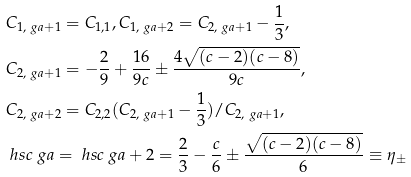Convert formula to latex. <formula><loc_0><loc_0><loc_500><loc_500>& C _ { 1 , \ g a + 1 } = C _ { 1 , 1 } , C _ { 1 , \ g a + 2 } = C _ { 2 , \ g a + 1 } - \frac { 1 } { 3 } , \\ & C _ { 2 , \ g a + 1 } = - \frac { 2 } { 9 } + \frac { 1 6 } { 9 c } \pm \frac { 4 \sqrt { ( c - 2 ) ( c - 8 ) } } { 9 c } , \\ & C _ { 2 , \ g a + 2 } = C _ { 2 , 2 } ( C _ { 2 , \ g a + 1 } - \frac { 1 } { 3 } ) / C _ { 2 , \ g a + 1 } , \\ & \ h s c { \ g a } = \ h s c { \ g a + 2 } = \frac { 2 } { 3 } - \frac { c } { 6 } \pm \frac { \sqrt { ( c - 2 ) ( c - 8 ) } } { 6 } \equiv \eta _ { \pm }</formula> 